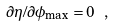<formula> <loc_0><loc_0><loc_500><loc_500>\partial \eta / \partial \phi _ { \max } = 0 \ ,</formula> 